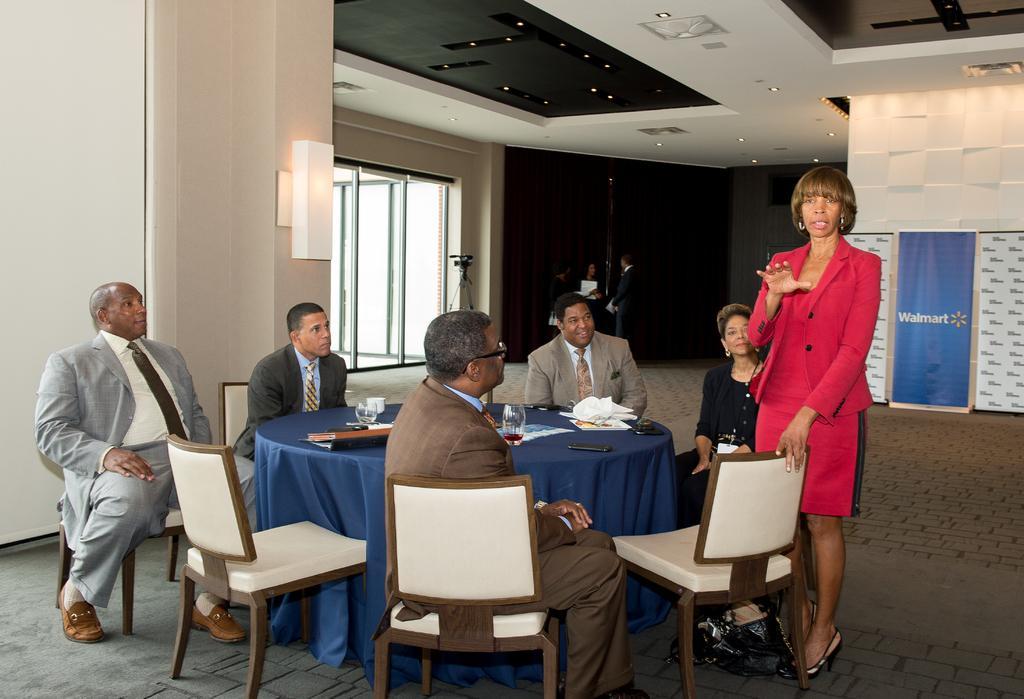In one or two sentences, can you explain what this image depicts? In the picture we can find a house in a house five people are sitting on the chairs near to the table and one woman is standing and explaining something. In the background we can find a window, wall and ceiling. And the ceiling is filled with lights. And the woman is explaining the information is wearing a red dress. And the people who are sitting in the chairs are wearing a blazer, tie and shirts. And the table is covered with cloth, tissues,glasses, papers. 